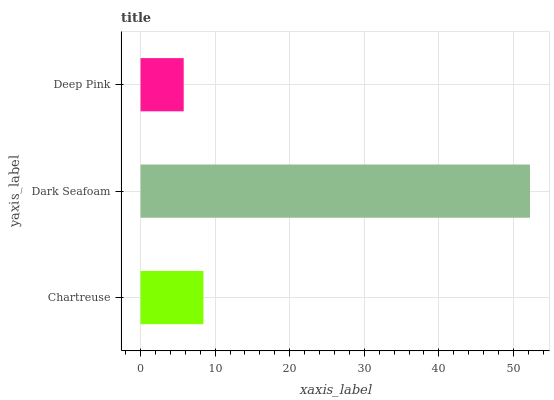Is Deep Pink the minimum?
Answer yes or no. Yes. Is Dark Seafoam the maximum?
Answer yes or no. Yes. Is Dark Seafoam the minimum?
Answer yes or no. No. Is Deep Pink the maximum?
Answer yes or no. No. Is Dark Seafoam greater than Deep Pink?
Answer yes or no. Yes. Is Deep Pink less than Dark Seafoam?
Answer yes or no. Yes. Is Deep Pink greater than Dark Seafoam?
Answer yes or no. No. Is Dark Seafoam less than Deep Pink?
Answer yes or no. No. Is Chartreuse the high median?
Answer yes or no. Yes. Is Chartreuse the low median?
Answer yes or no. Yes. Is Dark Seafoam the high median?
Answer yes or no. No. Is Dark Seafoam the low median?
Answer yes or no. No. 